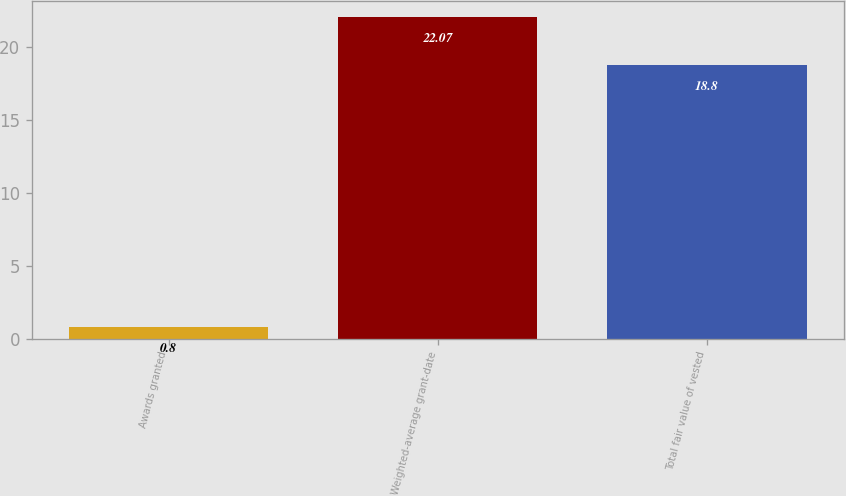<chart> <loc_0><loc_0><loc_500><loc_500><bar_chart><fcel>Awards granted<fcel>Weighted-average grant-date<fcel>Total fair value of vested<nl><fcel>0.8<fcel>22.07<fcel>18.8<nl></chart> 